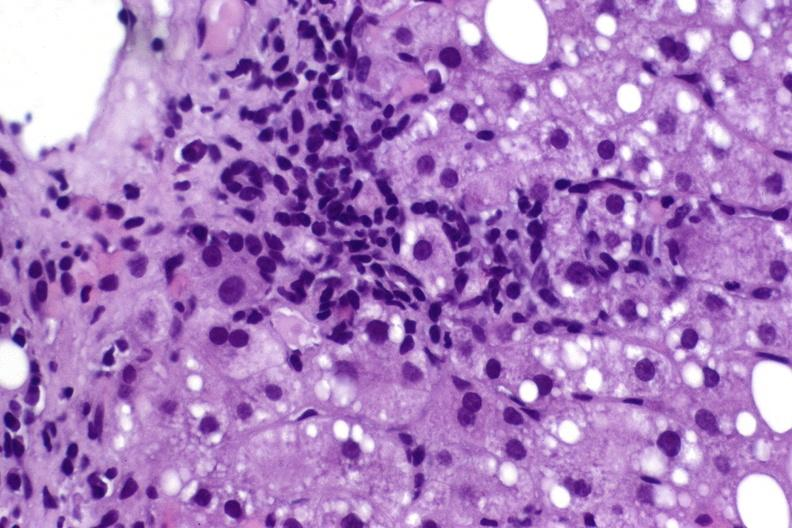what does this image show?
Answer the question using a single word or phrase. Hepatitis c virus 